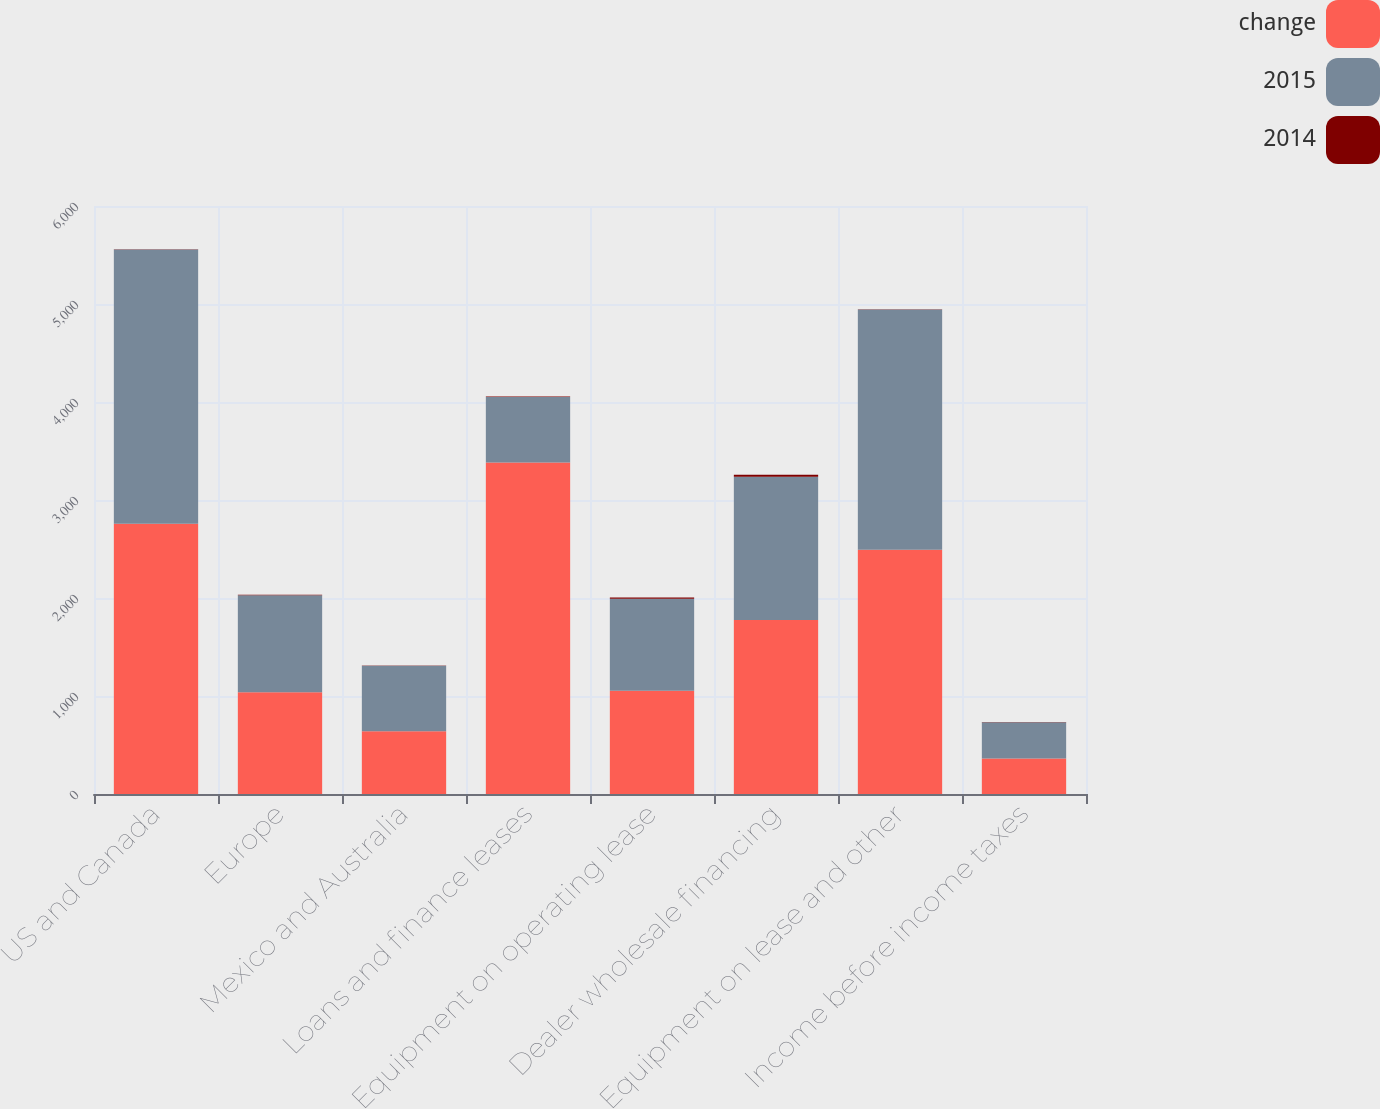<chart> <loc_0><loc_0><loc_500><loc_500><stacked_bar_chart><ecel><fcel>US and Canada<fcel>Europe<fcel>Mexico and Australia<fcel>Loans and finance leases<fcel>Equipment on operating lease<fcel>Dealer wholesale financing<fcel>Equipment on lease and other<fcel>Income before income taxes<nl><fcel>change<fcel>2758.7<fcel>1039<fcel>639.5<fcel>3383<fcel>1054.2<fcel>1775.2<fcel>2492.2<fcel>362.6<nl><fcel>2015<fcel>2798.3<fcel>988.1<fcel>668.7<fcel>668.7<fcel>938.4<fcel>1462<fcel>2452.9<fcel>370.4<nl><fcel>2014<fcel>1<fcel>5<fcel>4<fcel>4<fcel>12<fcel>21<fcel>2<fcel>2<nl></chart> 